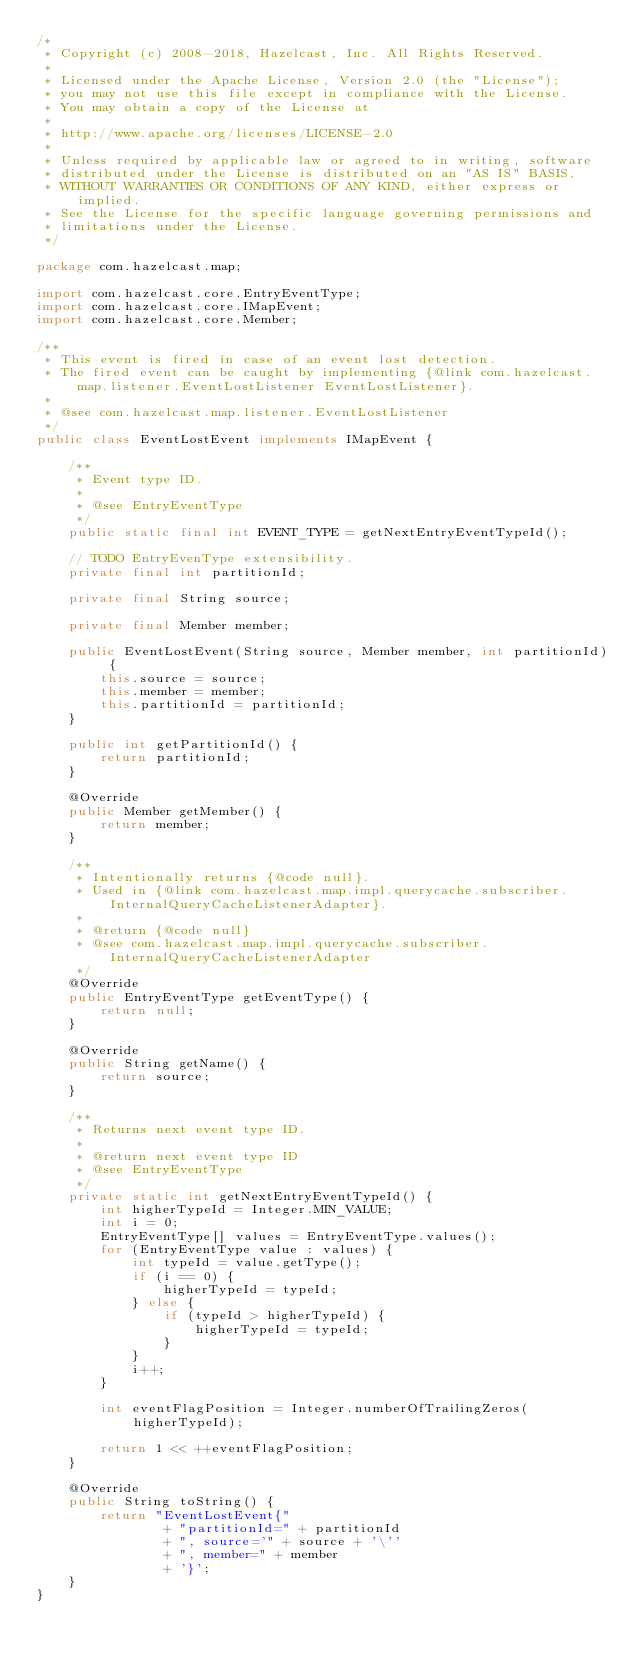<code> <loc_0><loc_0><loc_500><loc_500><_Java_>/*
 * Copyright (c) 2008-2018, Hazelcast, Inc. All Rights Reserved.
 *
 * Licensed under the Apache License, Version 2.0 (the "License");
 * you may not use this file except in compliance with the License.
 * You may obtain a copy of the License at
 *
 * http://www.apache.org/licenses/LICENSE-2.0
 *
 * Unless required by applicable law or agreed to in writing, software
 * distributed under the License is distributed on an "AS IS" BASIS,
 * WITHOUT WARRANTIES OR CONDITIONS OF ANY KIND, either express or implied.
 * See the License for the specific language governing permissions and
 * limitations under the License.
 */

package com.hazelcast.map;

import com.hazelcast.core.EntryEventType;
import com.hazelcast.core.IMapEvent;
import com.hazelcast.core.Member;

/**
 * This event is fired in case of an event lost detection.
 * The fired event can be caught by implementing {@link com.hazelcast.map.listener.EventLostListener EventLostListener}.
 *
 * @see com.hazelcast.map.listener.EventLostListener
 */
public class EventLostEvent implements IMapEvent {

    /**
     * Event type ID.
     *
     * @see EntryEventType
     */
    public static final int EVENT_TYPE = getNextEntryEventTypeId();

    // TODO EntryEvenType extensibility.
    private final int partitionId;

    private final String source;

    private final Member member;

    public EventLostEvent(String source, Member member, int partitionId) {
        this.source = source;
        this.member = member;
        this.partitionId = partitionId;
    }

    public int getPartitionId() {
        return partitionId;
    }

    @Override
    public Member getMember() {
        return member;
    }

    /**
     * Intentionally returns {@code null}.
     * Used in {@link com.hazelcast.map.impl.querycache.subscriber.InternalQueryCacheListenerAdapter}.
     *
     * @return {@code null}
     * @see com.hazelcast.map.impl.querycache.subscriber.InternalQueryCacheListenerAdapter
     */
    @Override
    public EntryEventType getEventType() {
        return null;
    }

    @Override
    public String getName() {
        return source;
    }

    /**
     * Returns next event type ID.
     *
     * @return next event type ID
     * @see EntryEventType
     */
    private static int getNextEntryEventTypeId() {
        int higherTypeId = Integer.MIN_VALUE;
        int i = 0;
        EntryEventType[] values = EntryEventType.values();
        for (EntryEventType value : values) {
            int typeId = value.getType();
            if (i == 0) {
                higherTypeId = typeId;
            } else {
                if (typeId > higherTypeId) {
                    higherTypeId = typeId;
                }
            }
            i++;
        }

        int eventFlagPosition = Integer.numberOfTrailingZeros(higherTypeId);

        return 1 << ++eventFlagPosition;
    }

    @Override
    public String toString() {
        return "EventLostEvent{"
                + "partitionId=" + partitionId
                + ", source='" + source + '\''
                + ", member=" + member
                + '}';
    }
}
</code> 